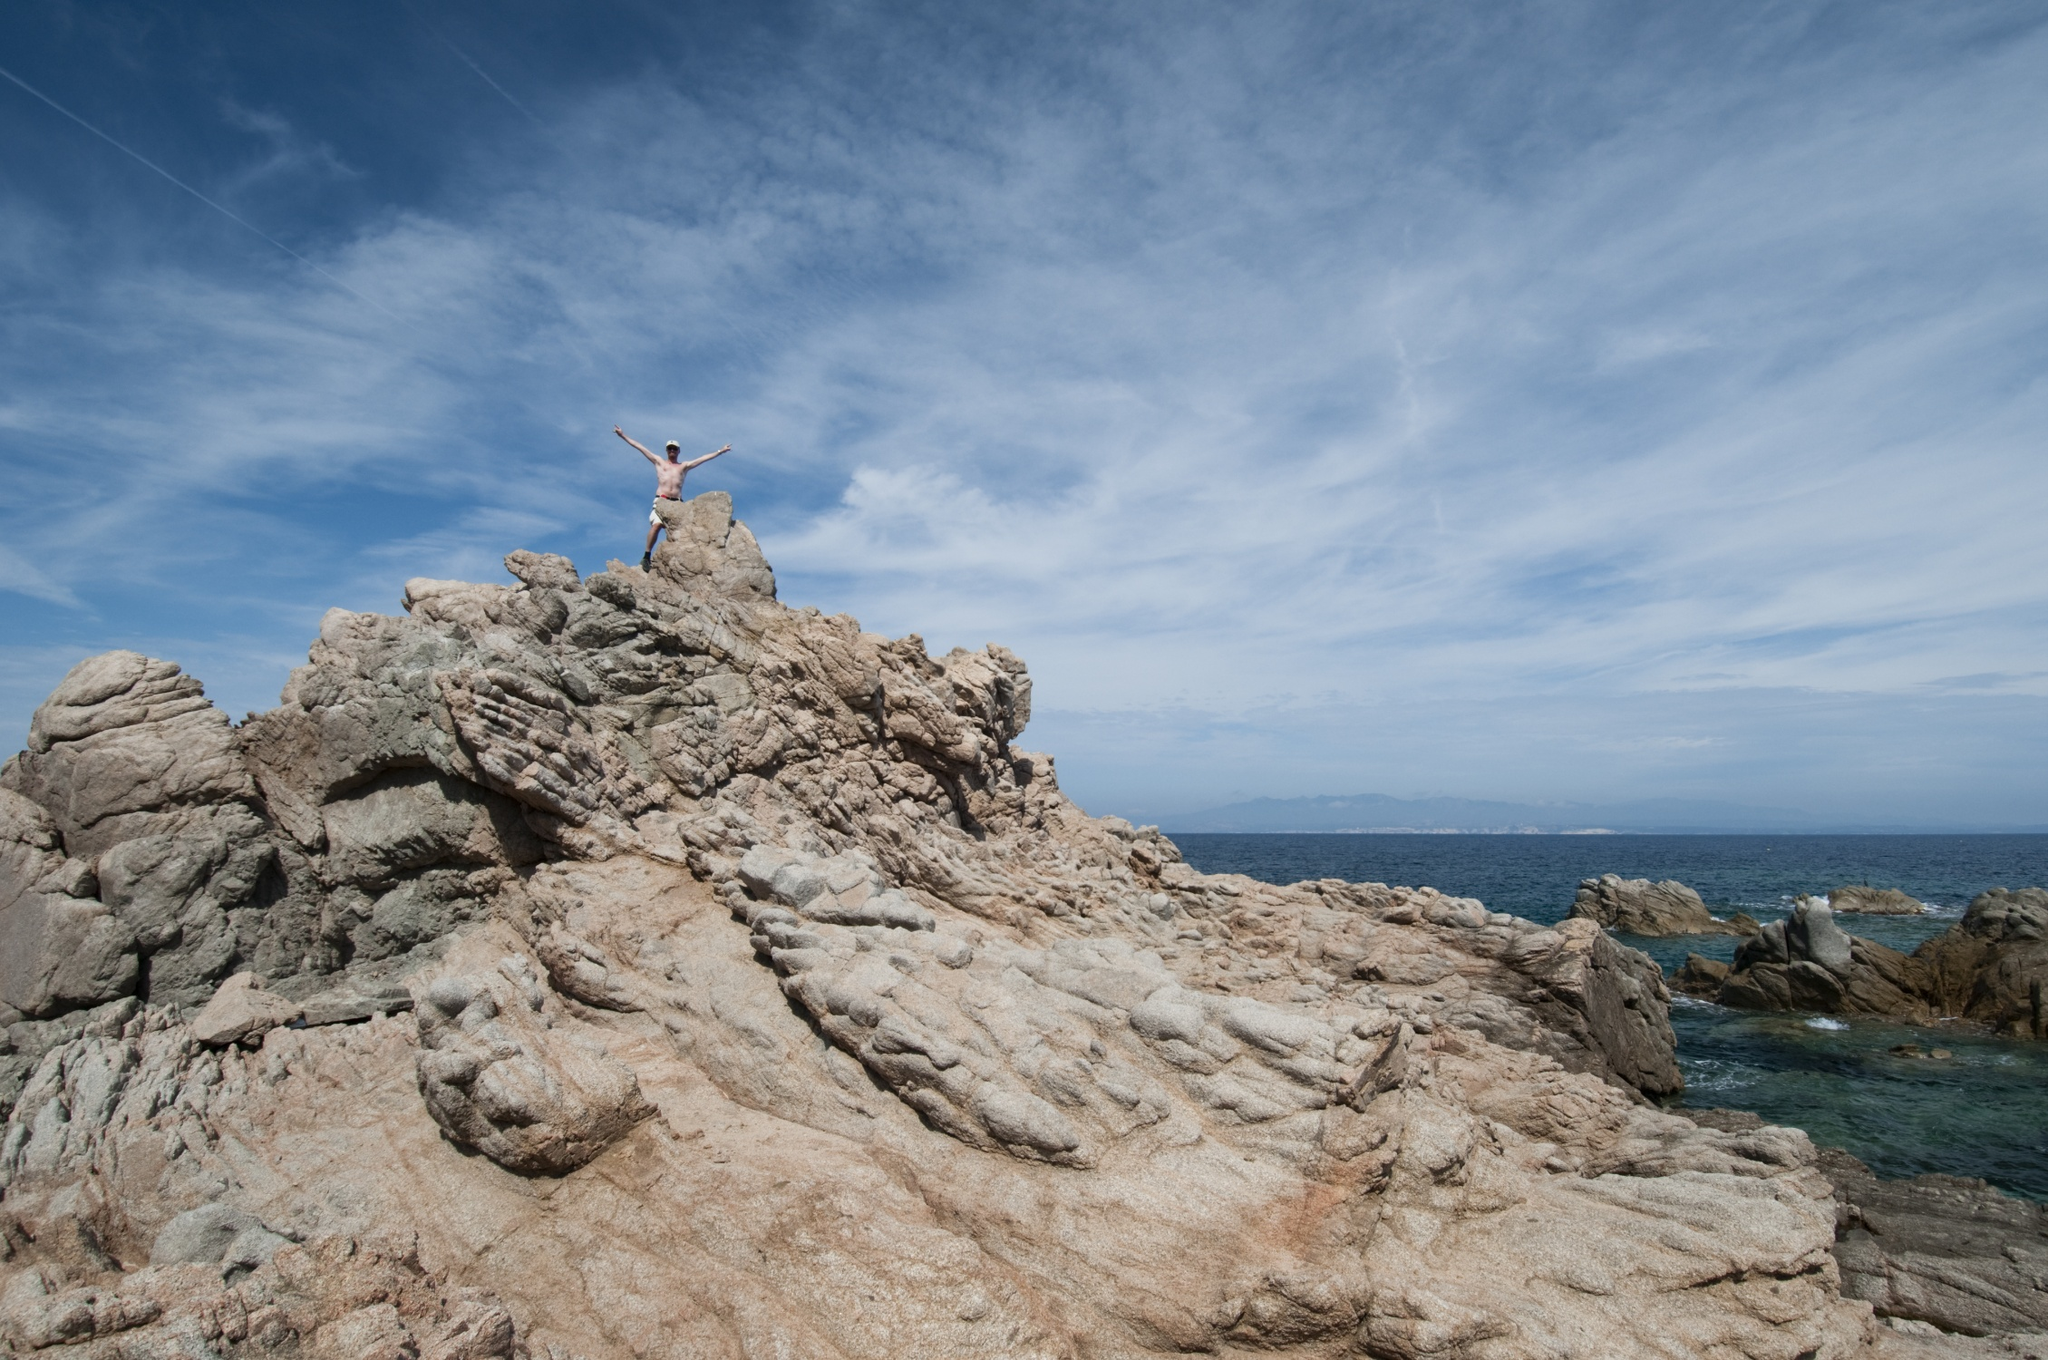If you were to imagine a realistic scenario based on this image, what could be happening? This image could depict a dedicated hiker or adventurer who has reached the summit of a challenging coastal trail. They've paused to relish the moment, standing on the highest point of the cliff, savoring the sense of accomplishment and the breathtaking view. The vast ocean and clear sky ahead symbolize the endless opportunities and experiences awaiting them, while the rugged cliff they've conquered serves as a testament to their determination and resilience.  Can you give a shorter, realistic scenario? A person has reached the top of a rocky cliff during a coastal hike and is celebrating the spectacular view of the ocean by spreading their arms in triumph. 